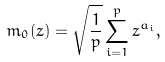Convert formula to latex. <formula><loc_0><loc_0><loc_500><loc_500>m _ { 0 } ( z ) = \sqrt { \frac { 1 } { p } } \sum _ { i = 1 } ^ { p } z ^ { a _ { i } } ,</formula> 